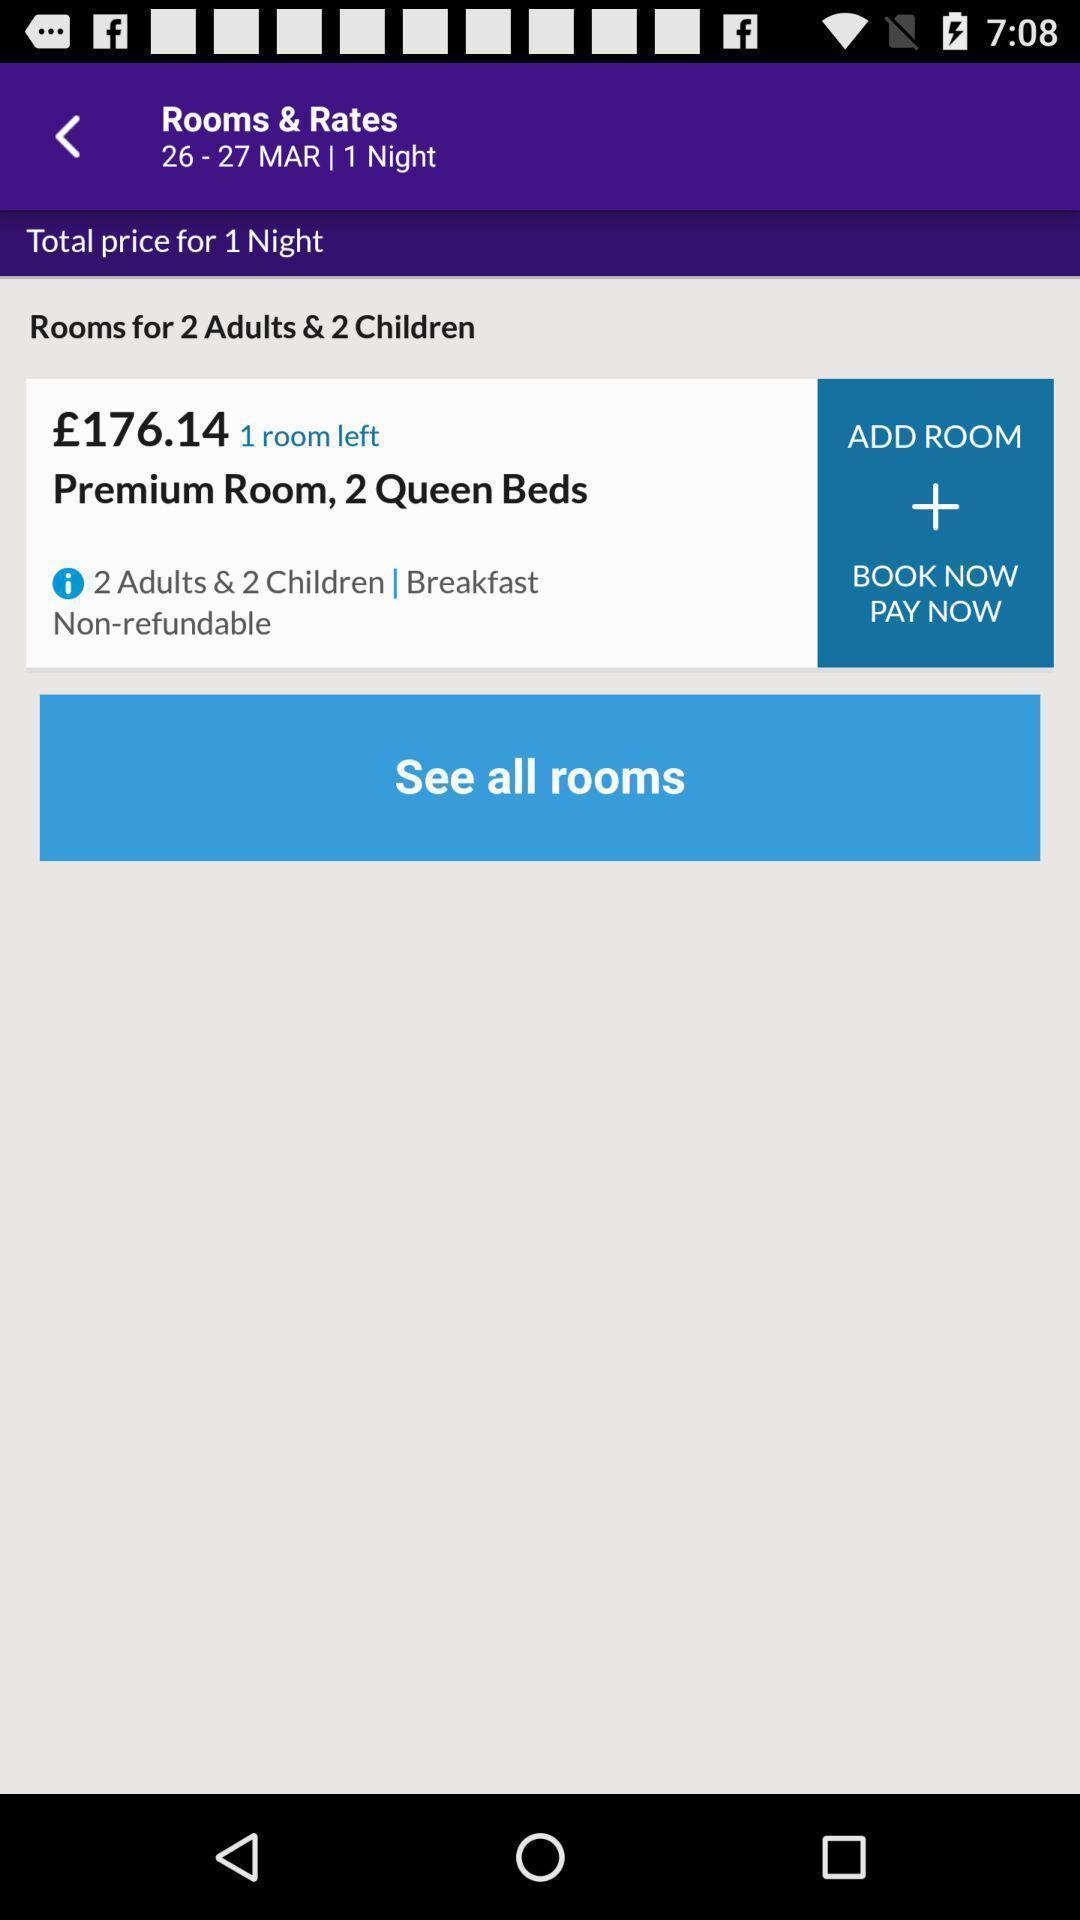What is the overall content of this screenshot? Page displaying the hotel rooms available. 